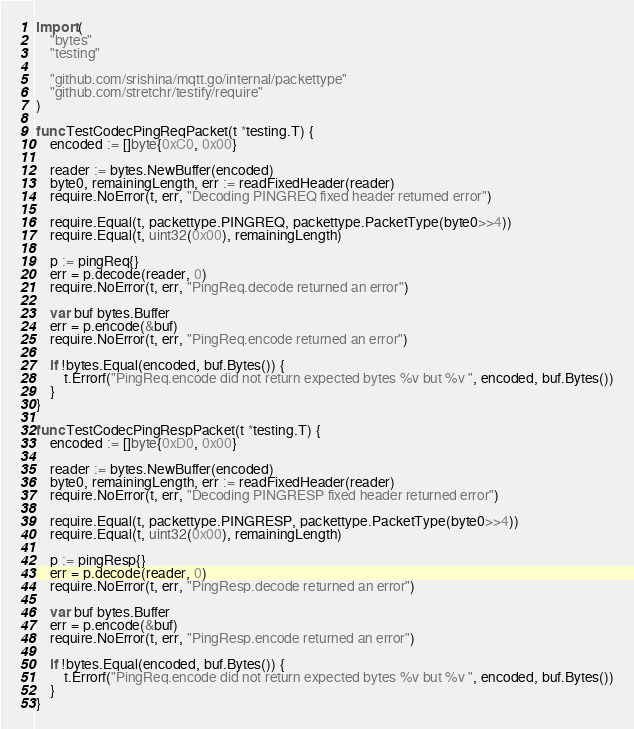<code> <loc_0><loc_0><loc_500><loc_500><_Go_>
import (
	"bytes"
	"testing"

	"github.com/srishina/mqtt.go/internal/packettype"
	"github.com/stretchr/testify/require"
)

func TestCodecPingReqPacket(t *testing.T) {
	encoded := []byte{0xC0, 0x00}

	reader := bytes.NewBuffer(encoded)
	byte0, remainingLength, err := readFixedHeader(reader)
	require.NoError(t, err, "Decoding PINGREQ fixed header returned error")

	require.Equal(t, packettype.PINGREQ, packettype.PacketType(byte0>>4))
	require.Equal(t, uint32(0x00), remainingLength)

	p := pingReq{}
	err = p.decode(reader, 0)
	require.NoError(t, err, "PingReq.decode returned an error")

	var buf bytes.Buffer
	err = p.encode(&buf)
	require.NoError(t, err, "PingReq.encode returned an error")

	if !bytes.Equal(encoded, buf.Bytes()) {
		t.Errorf("PingReq.encode did not return expected bytes %v but %v ", encoded, buf.Bytes())
	}
}

func TestCodecPingRespPacket(t *testing.T) {
	encoded := []byte{0xD0, 0x00}

	reader := bytes.NewBuffer(encoded)
	byte0, remainingLength, err := readFixedHeader(reader)
	require.NoError(t, err, "Decoding PINGRESP fixed header returned error")

	require.Equal(t, packettype.PINGRESP, packettype.PacketType(byte0>>4))
	require.Equal(t, uint32(0x00), remainingLength)

	p := pingResp{}
	err = p.decode(reader, 0)
	require.NoError(t, err, "PingResp.decode returned an error")

	var buf bytes.Buffer
	err = p.encode(&buf)
	require.NoError(t, err, "PingResp.encode returned an error")

	if !bytes.Equal(encoded, buf.Bytes()) {
		t.Errorf("PingReq.encode did not return expected bytes %v but %v ", encoded, buf.Bytes())
	}
}
</code> 